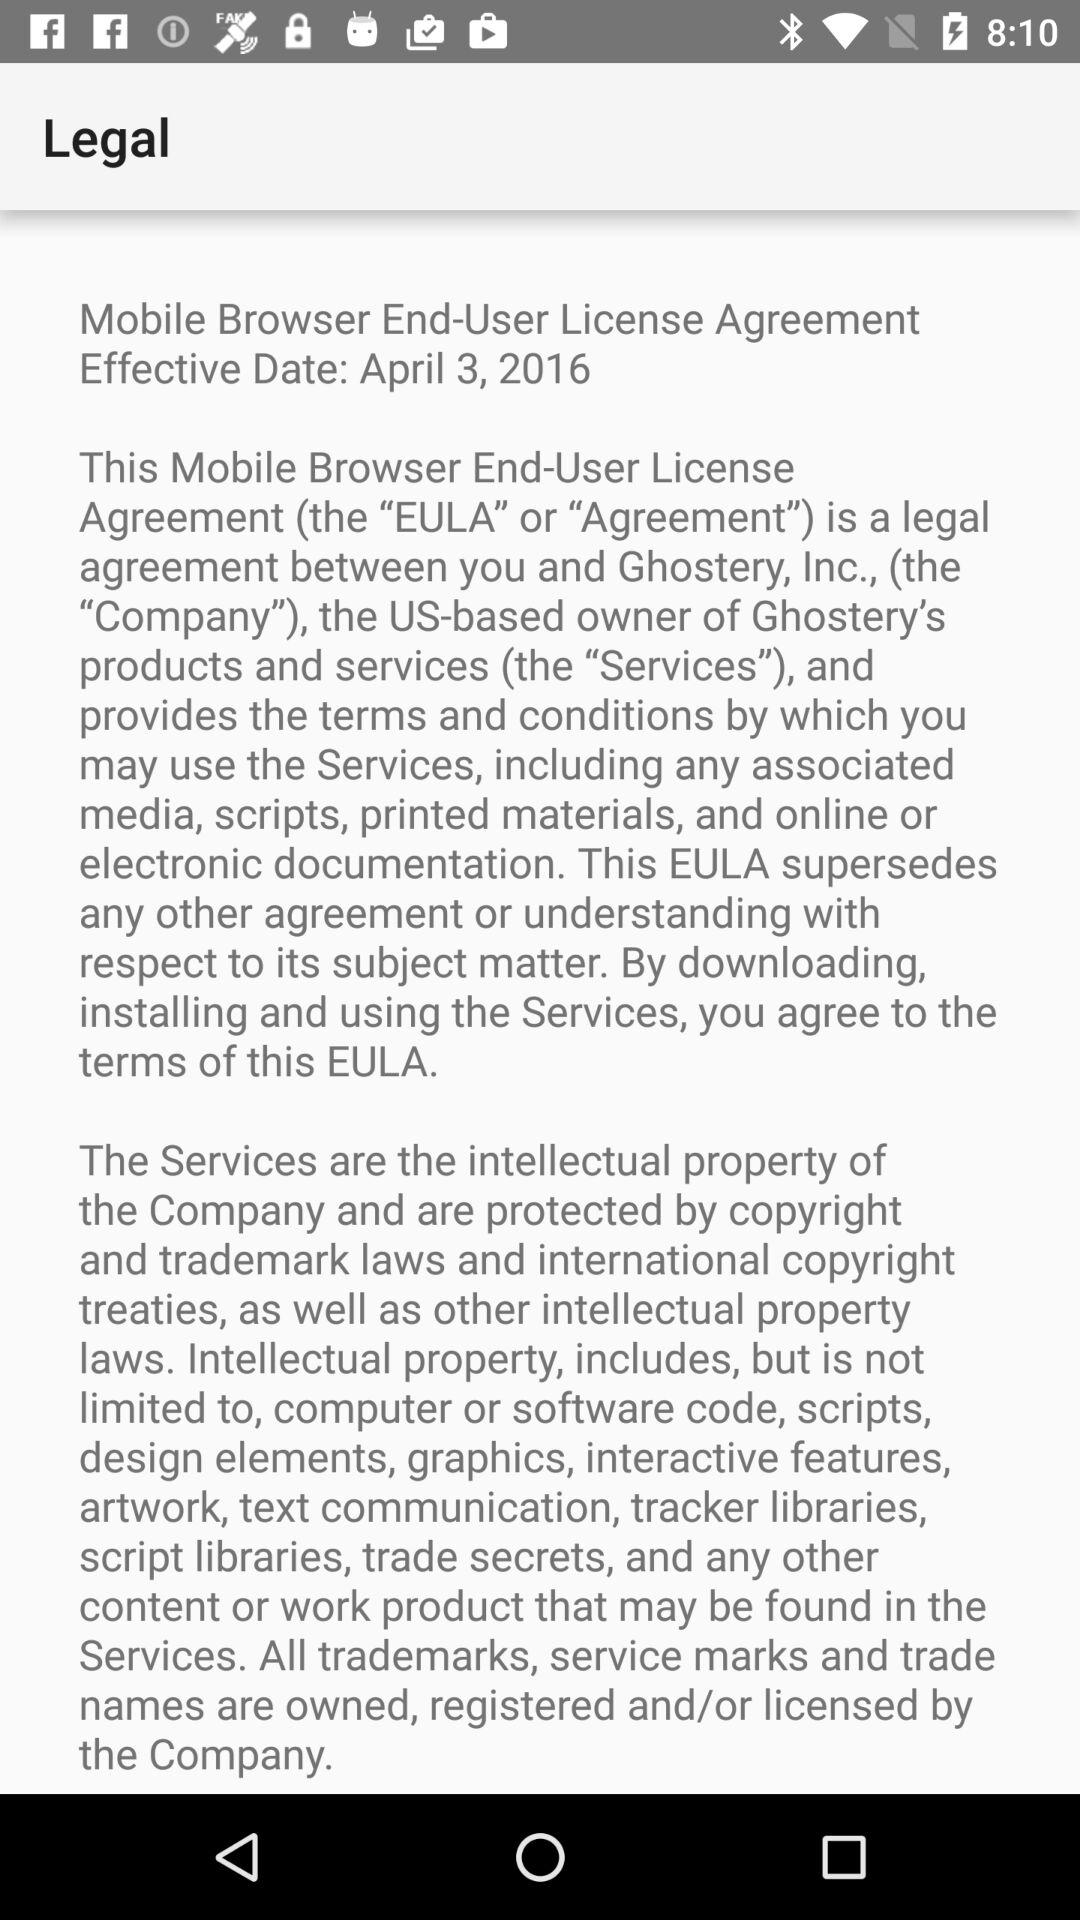What is the full form of EULA? The full form of EULA is End-User License Agreement. 